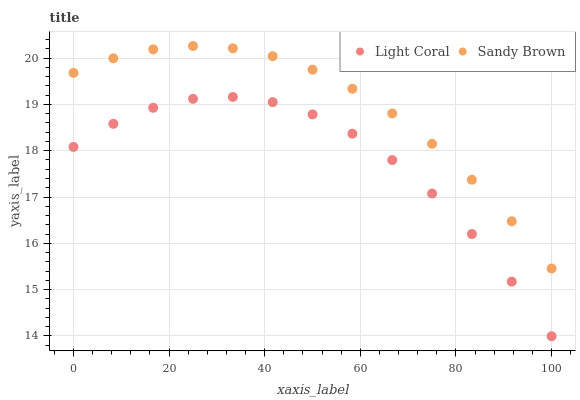Does Light Coral have the minimum area under the curve?
Answer yes or no. Yes. Does Sandy Brown have the maximum area under the curve?
Answer yes or no. Yes. Does Sandy Brown have the minimum area under the curve?
Answer yes or no. No. Is Sandy Brown the smoothest?
Answer yes or no. Yes. Is Light Coral the roughest?
Answer yes or no. Yes. Is Sandy Brown the roughest?
Answer yes or no. No. Does Light Coral have the lowest value?
Answer yes or no. Yes. Does Sandy Brown have the lowest value?
Answer yes or no. No. Does Sandy Brown have the highest value?
Answer yes or no. Yes. Is Light Coral less than Sandy Brown?
Answer yes or no. Yes. Is Sandy Brown greater than Light Coral?
Answer yes or no. Yes. Does Light Coral intersect Sandy Brown?
Answer yes or no. No. 